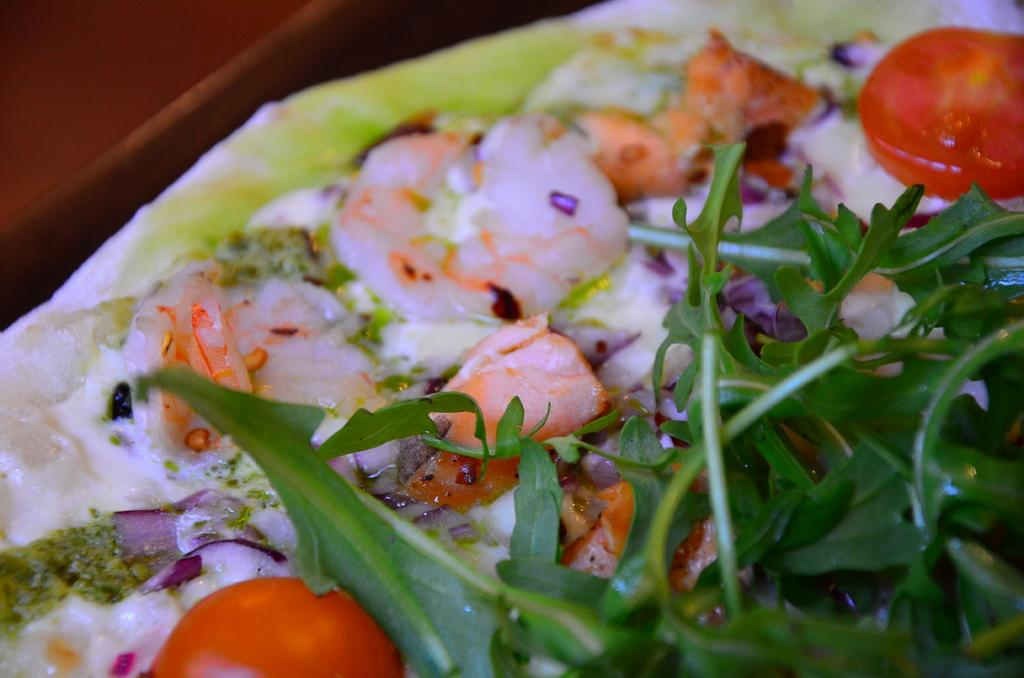What types of items can be seen in the image? There are food items in the image. Can you describe the food items in more detail? Unfortunately, the provided facts do not offer enough information to describe the food items in more detail. What type of fang can be seen in the image? There is no fang present in the image; it only contains food items. 